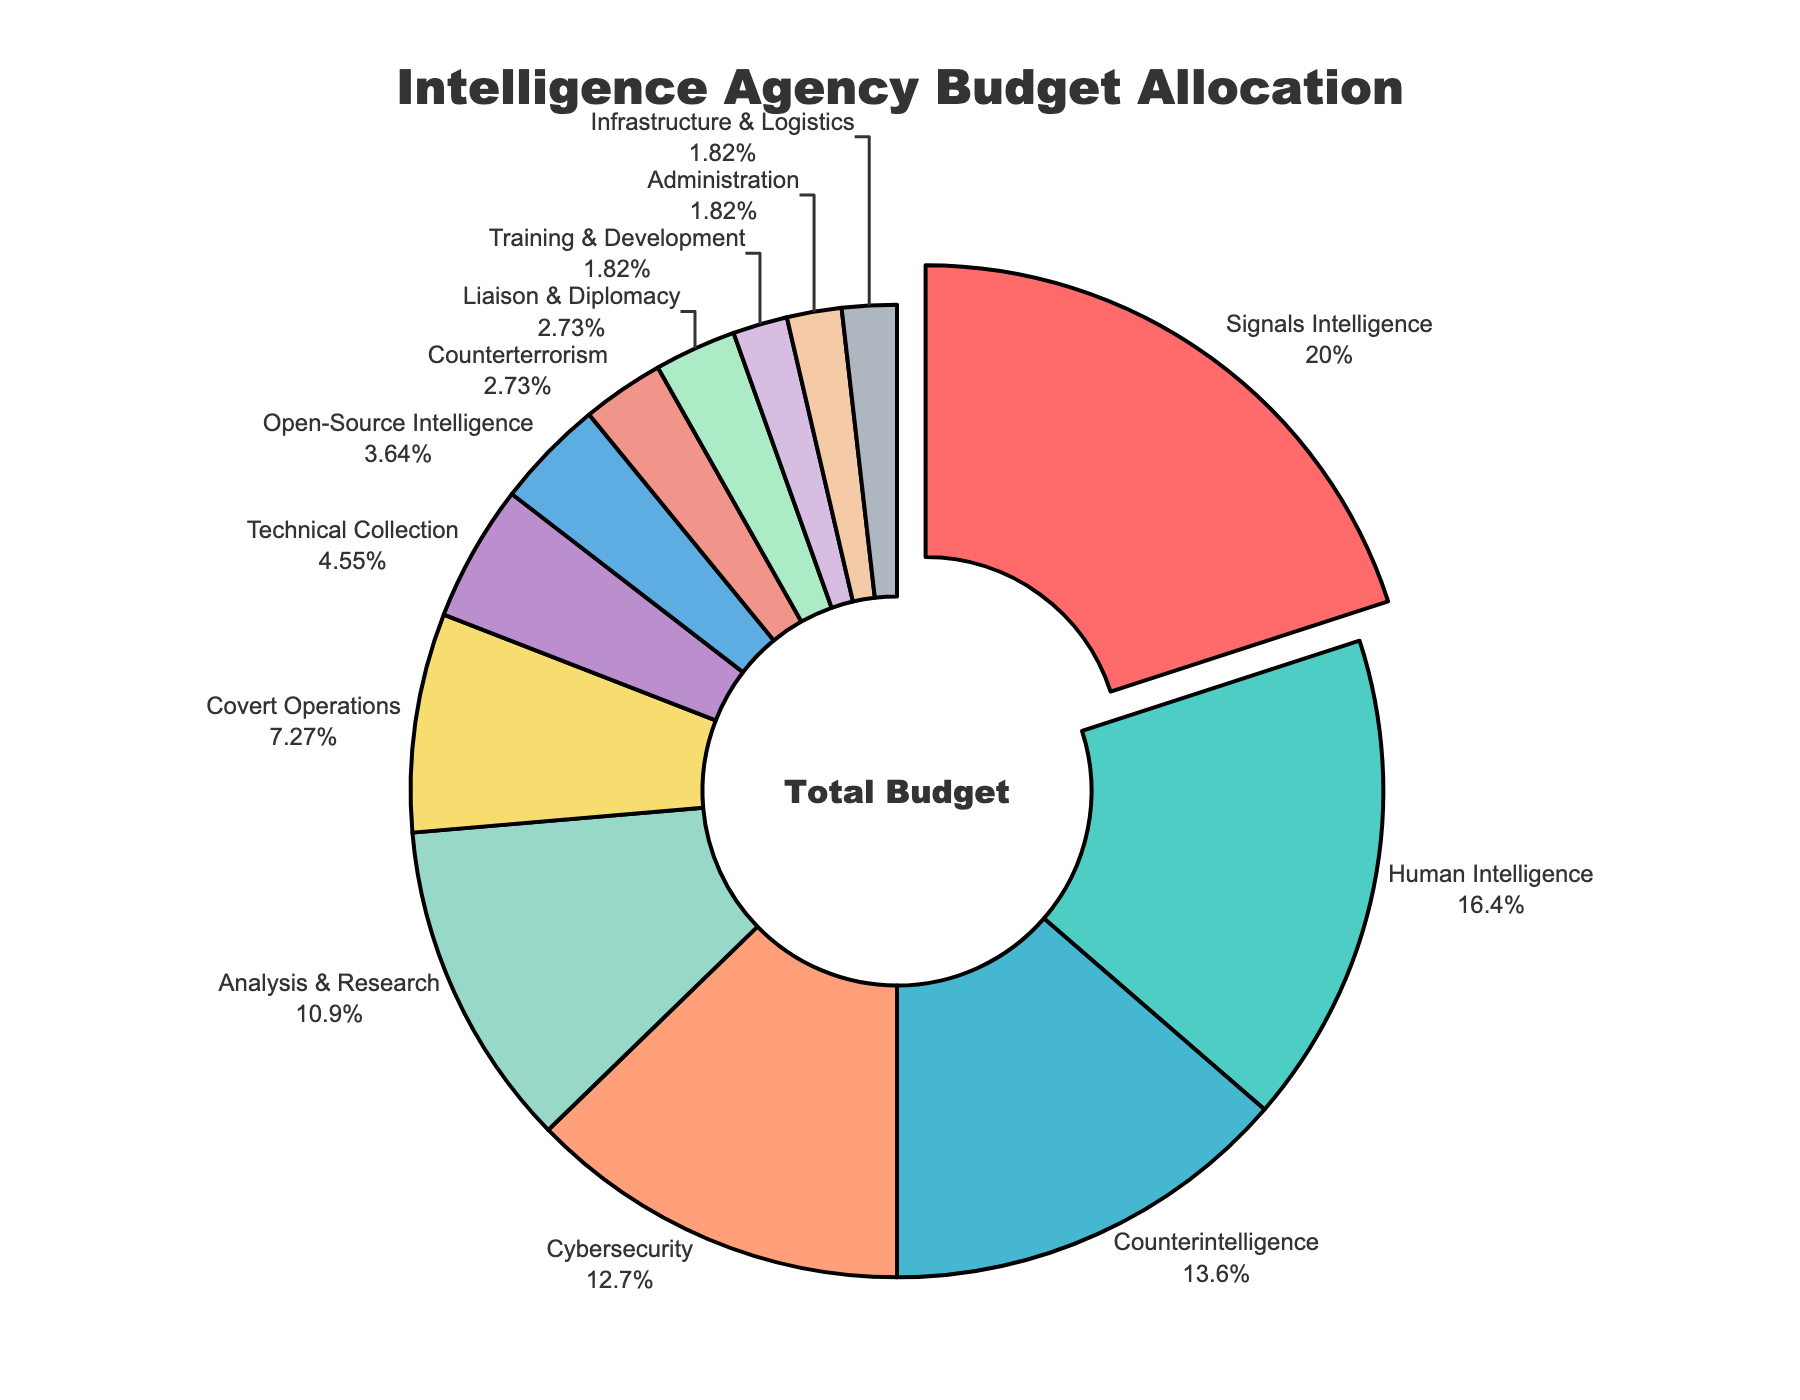Which operational area has the highest budget allocation percentage? The pie chart segments highlight the allocation with "Signals Intelligence" being pulled out. The label indicates it has 22%.
Answer: Signals Intelligence Which operational area receives the least budget allocation? The smallest segments are labeled and visually represented as having the lowest percentage. "Training & Development," "Administration," and "Infrastructure & Logistics" each have 2%.
Answer: Training & Development, Administration, and Infrastructure & Logistics How much more budget percentage is allocated to Cybersecurity compared to Covert Operations? Cybersecurity is allocated 14% while Covert Operations is allocated 8%. The difference is calculated as 14% - 8%.
Answer: 6% What is the combined budget allocation for Counterintelligence, Counterterrorism, and Liaison & Diplomacy? Adding the percentages for Counterintelligence (15%), Counterterrorism (3%), and Liaison & Diplomacy (3%) results in 15% + 3% + 3%.
Answer: 21% Which operational areas have budget allocations equal to or greater than 10%? By examining the pie chart, the segments labeled "Signals Intelligence," "Human Intelligence," "Counterintelligence," "Cybersecurity," and "Analysis & Research" are each 10% or more.
Answer: Signals Intelligence, Human Intelligence, Counterintelligence, Cybersecurity, and Analysis & Research What fraction of the total budget is allocated to Technical Collection and Open-Source Intelligence combined? Combining percentages for Technical Collection (5%) and Open-Source Intelligence (4%) gives 5% + 4%. This equals 9%, which is 9/100 in fraction form.
Answer: 9/100 Compare the budget percentages of Human Intelligence and Analysis & Research. Which one is larger and by how much? Human Intelligence has 18% and Analysis & Research has 12%. The difference is calculated as 18% - 12%. Human Intelligence's budget is larger by this amount.
Answer: Human Intelligence by 6% Is the budget allocation for Signals Intelligence more than double that of Covert Operations? Signals Intelligence has an allocation of 22%, while Covert Operations has 8%. We check if 22% is more than 2 * 8% (16%). Since 22% > 16%, the answer is yes.
Answer: Yes What percentage of the budget is dedicated to non-operational areas like Administration and Infrastructure & Logistics combined? Adding the percentages for Administration (2%) and Infrastructure & Logistics (2%) results in 2% + 2%.
Answer: 4% What is the average budget allocation for the top three highest funded operational areas? The top three areas are Signals Intelligence (22%), Human Intelligence (18%), and Counterintelligence (15%). The average is calculated by taking (22 + 18 + 15) / 3.
Answer: 18.33% 